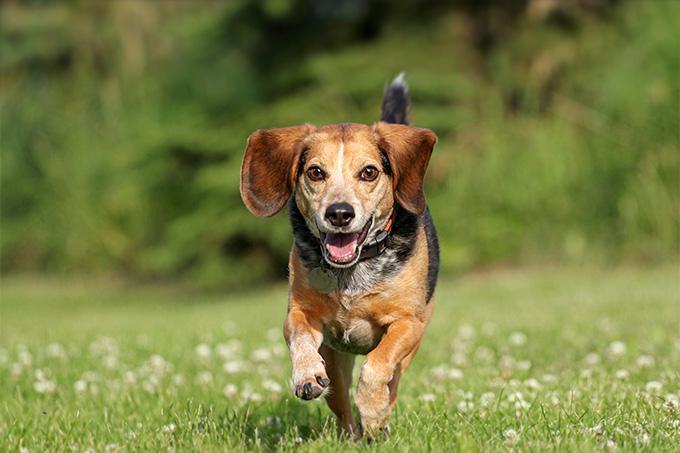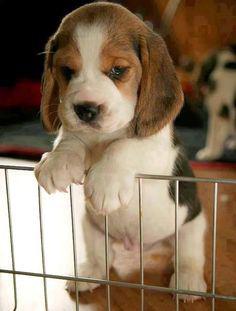The first image is the image on the left, the second image is the image on the right. Given the left and right images, does the statement "a beagle sitting in the grass has dog tags on it's collar" hold true? Answer yes or no. No. The first image is the image on the left, the second image is the image on the right. Given the left and right images, does the statement "There is at least one puppy in one of the pictures." hold true? Answer yes or no. Yes. 